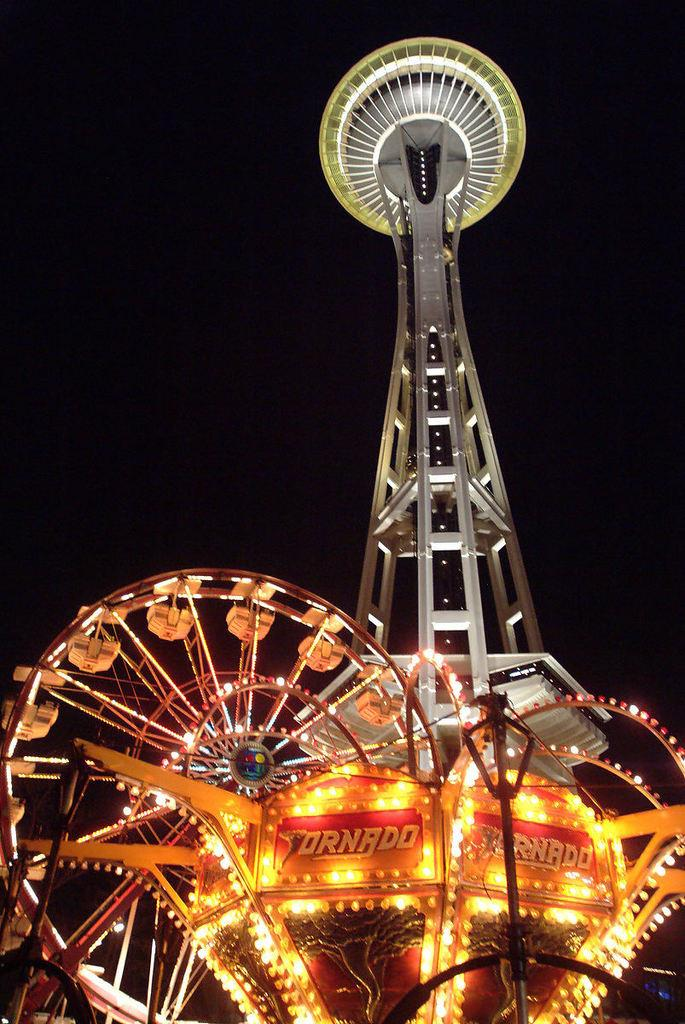What structure is located on the right side of the image? There is a tower on the right side of the image. What type of wheel can be seen in the image? There is a joint wheel with lights in the image. What are the tall, thin objects in the image? There are poles in the image. What other objects can be seen at the bottom of the image? There are other objects at the bottom of the image, but their specific details are not mentioned in the provided facts. How many pets are visible in the image? There are no pets present in the image. What actor is performing in the image? There is no actor performing in the image. 